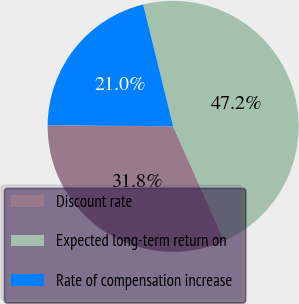<chart> <loc_0><loc_0><loc_500><loc_500><pie_chart><fcel>Discount rate<fcel>Expected long-term return on<fcel>Rate of compensation increase<nl><fcel>31.82%<fcel>47.16%<fcel>21.02%<nl></chart> 